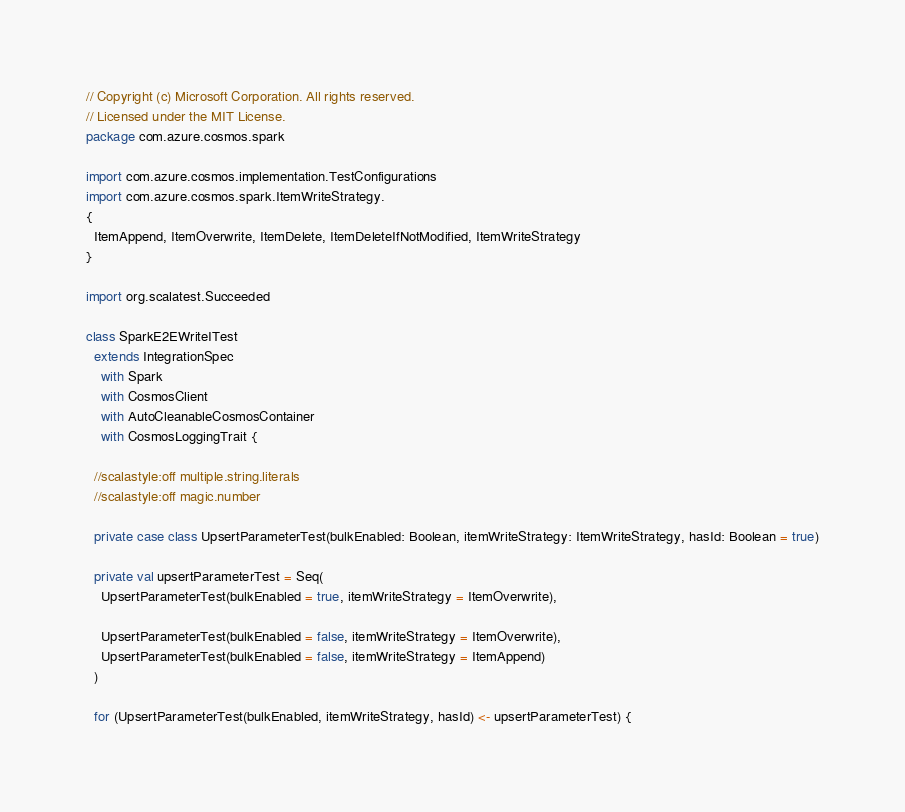Convert code to text. <code><loc_0><loc_0><loc_500><loc_500><_Scala_>// Copyright (c) Microsoft Corporation. All rights reserved.
// Licensed under the MIT License.
package com.azure.cosmos.spark

import com.azure.cosmos.implementation.TestConfigurations
import com.azure.cosmos.spark.ItemWriteStrategy.
{
  ItemAppend, ItemOverwrite, ItemDelete, ItemDeleteIfNotModified, ItemWriteStrategy
}

import org.scalatest.Succeeded

class SparkE2EWriteITest
  extends IntegrationSpec
    with Spark
    with CosmosClient
    with AutoCleanableCosmosContainer
    with CosmosLoggingTrait {

  //scalastyle:off multiple.string.literals
  //scalastyle:off magic.number

  private case class UpsertParameterTest(bulkEnabled: Boolean, itemWriteStrategy: ItemWriteStrategy, hasId: Boolean = true)

  private val upsertParameterTest = Seq(
    UpsertParameterTest(bulkEnabled = true, itemWriteStrategy = ItemOverwrite),

    UpsertParameterTest(bulkEnabled = false, itemWriteStrategy = ItemOverwrite),
    UpsertParameterTest(bulkEnabled = false, itemWriteStrategy = ItemAppend)
  )

  for (UpsertParameterTest(bulkEnabled, itemWriteStrategy, hasId) <- upsertParameterTest) {</code> 